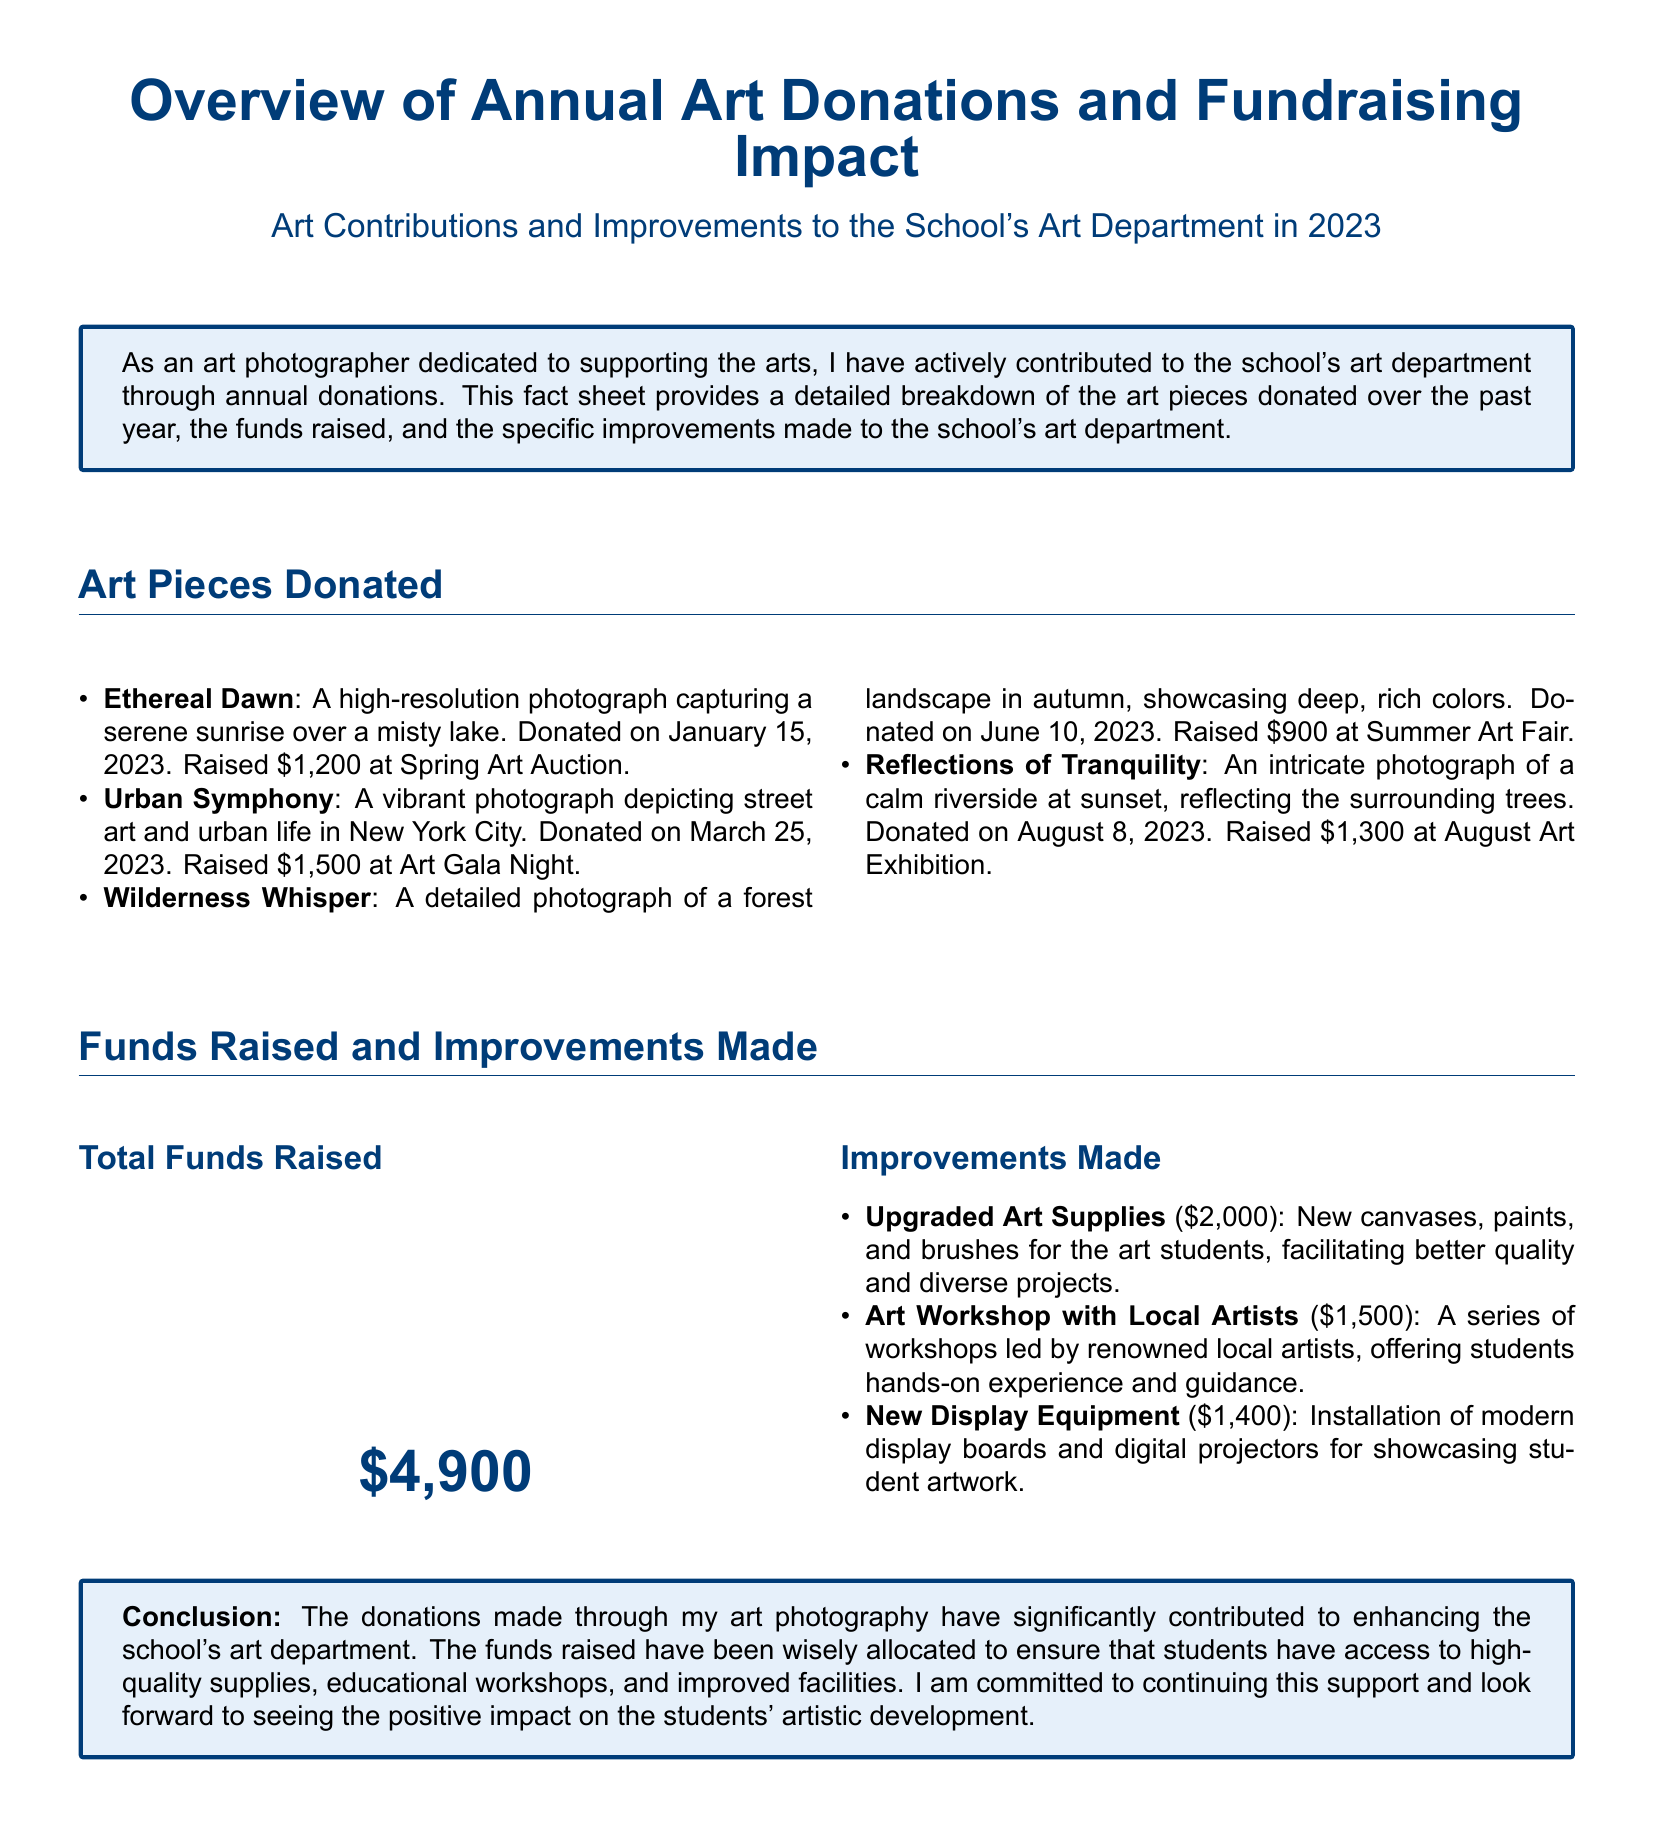What is the total amount raised from donations? The total amount raised is stated in the document under "Total Funds Raised" as $4,900.
Answer: $4,900 What piece raised the highest amount? By comparing the funds raised for each art piece, "Urban Symphony" raised the most at $1,500.
Answer: Urban Symphony When was "Reflections of Tranquility" donated? The donation date for "Reflections of Tranquility" is provided as August 8, 2023.
Answer: August 8, 2023 What improvement cost $2,000? The document mentions that "Upgraded Art Supplies" amounted to $2,000.
Answer: Upgraded Art Supplies How many art pieces were donated last year? The document lists four art pieces donated over the past year.
Answer: Four What type of event contributed to raising $1,300? The associated event for raising $1,300 is identified as "August Art Exhibition."
Answer: August Art Exhibition Which artist-led initiative had a budget of $1,500? The document specifies that the series of workshops led by local artists costs $1,500.
Answer: Art Workshop with Local Artists What is the main focus of this fact sheet? The fact sheet primarily focuses on the contributions made to the school's art department through art donations.
Answer: Contributions to the school's art department What improvements were made to display student artwork? The document states that "New Display Equipment" was installed for showcasing artwork.
Answer: New Display Equipment 